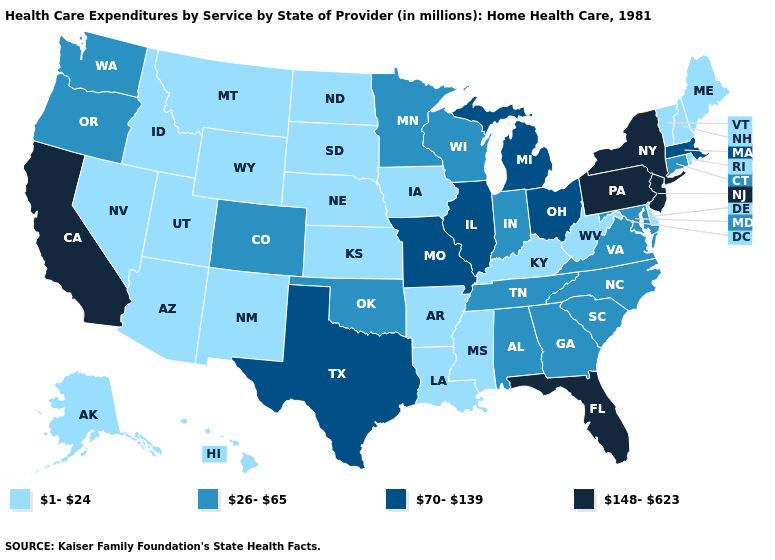What is the lowest value in the USA?
Short answer required. 1-24. What is the highest value in states that border Wisconsin?
Quick response, please. 70-139. Does New York have the same value as South Carolina?
Short answer required. No. What is the value of Illinois?
Short answer required. 70-139. Among the states that border Colorado , which have the highest value?
Give a very brief answer. Oklahoma. Name the states that have a value in the range 26-65?
Concise answer only. Alabama, Colorado, Connecticut, Georgia, Indiana, Maryland, Minnesota, North Carolina, Oklahoma, Oregon, South Carolina, Tennessee, Virginia, Washington, Wisconsin. What is the highest value in states that border Michigan?
Answer briefly. 70-139. Name the states that have a value in the range 148-623?
Give a very brief answer. California, Florida, New Jersey, New York, Pennsylvania. Does the first symbol in the legend represent the smallest category?
Give a very brief answer. Yes. Among the states that border Maine , which have the highest value?
Be succinct. New Hampshire. What is the lowest value in states that border West Virginia?
Concise answer only. 1-24. What is the value of New Mexico?
Give a very brief answer. 1-24. Does the first symbol in the legend represent the smallest category?
Give a very brief answer. Yes. Does the map have missing data?
Give a very brief answer. No. What is the value of Arizona?
Quick response, please. 1-24. 